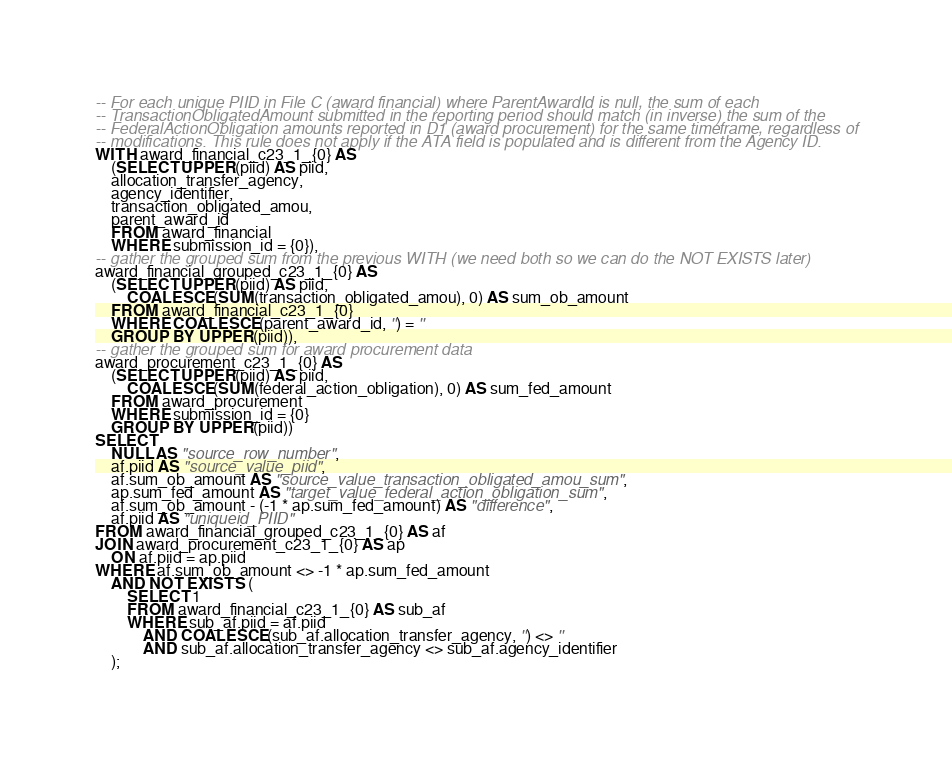<code> <loc_0><loc_0><loc_500><loc_500><_SQL_>-- For each unique PIID in File C (award financial) where ParentAwardId is null, the sum of each
-- TransactionObligatedAmount submitted in the reporting period should match (in inverse) the sum of the
-- FederalActionObligation amounts reported in D1 (award procurement) for the same timeframe, regardless of
-- modifications. This rule does not apply if the ATA field is populated and is different from the Agency ID.
WITH award_financial_c23_1_{0} AS
    (SELECT UPPER(piid) AS piid,
    allocation_transfer_agency,
    agency_identifier,
    transaction_obligated_amou,
    parent_award_id
    FROM award_financial
    WHERE submission_id = {0}),
-- gather the grouped sum from the previous WITH (we need both so we can do the NOT EXISTS later)
award_financial_grouped_c23_1_{0} AS
    (SELECT UPPER(piid) AS piid,
        COALESCE(SUM(transaction_obligated_amou), 0) AS sum_ob_amount
    FROM award_financial_c23_1_{0}
    WHERE COALESCE(parent_award_id, '') = ''
    GROUP BY UPPER(piid)),
-- gather the grouped sum for award procurement data
award_procurement_c23_1_{0} AS
    (SELECT UPPER(piid) AS piid,
        COALESCE(SUM(federal_action_obligation), 0) AS sum_fed_amount
    FROM award_procurement
    WHERE submission_id = {0}
    GROUP BY UPPER(piid))
SELECT
    NULL AS "source_row_number",
    af.piid AS "source_value_piid",
    af.sum_ob_amount AS "source_value_transaction_obligated_amou_sum",
    ap.sum_fed_amount AS "target_value_federal_action_obligation_sum",
    af.sum_ob_amount - (-1 * ap.sum_fed_amount) AS "difference",
    af.piid AS "uniqueid_PIID"
FROM award_financial_grouped_c23_1_{0} AS af
JOIN award_procurement_c23_1_{0} AS ap
    ON af.piid = ap.piid
WHERE af.sum_ob_amount <> -1 * ap.sum_fed_amount
    AND NOT EXISTS (
        SELECT 1
        FROM award_financial_c23_1_{0} AS sub_af
        WHERE sub_af.piid = af.piid
            AND COALESCE(sub_af.allocation_transfer_agency, '') <> ''
            AND sub_af.allocation_transfer_agency <> sub_af.agency_identifier
    );
</code> 